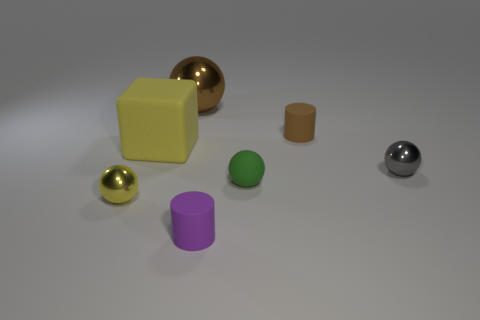Is the shape of the small object left of the yellow rubber block the same as the tiny metal thing behind the green thing?
Offer a very short reply. Yes. Does the gray metal object have the same size as the cylinder that is in front of the brown rubber thing?
Your response must be concise. Yes. How many other objects are the same material as the tiny brown object?
Your answer should be compact. 3. Are there any other things that have the same shape as the yellow matte thing?
Offer a terse response. No. There is a big object that is behind the small rubber cylinder behind the tiny gray object right of the yellow sphere; what is its color?
Provide a short and direct response. Brown. There is a rubber thing that is behind the green sphere and in front of the small brown rubber cylinder; what shape is it?
Keep it short and to the point. Cube. There is a tiny rubber cylinder behind the tiny metal ball behind the yellow metal ball; what is its color?
Keep it short and to the point. Brown. What is the shape of the metal thing behind the shiny ball on the right side of the rubber cylinder that is right of the tiny purple object?
Make the answer very short. Sphere. There is a matte object that is both left of the green rubber ball and behind the purple object; what size is it?
Keep it short and to the point. Large. How many small things are the same color as the cube?
Offer a very short reply. 1. 